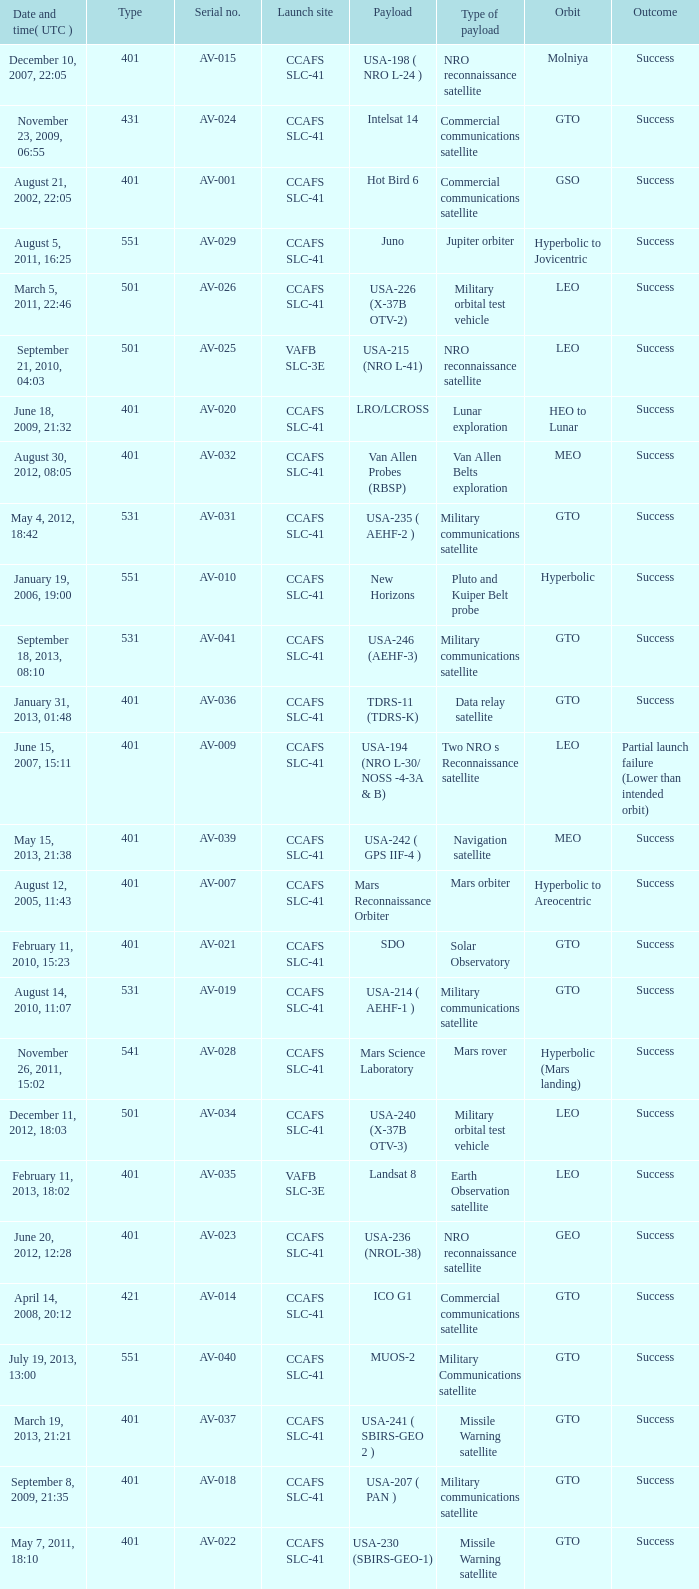When was the payload of Commercial Communications Satellite amc16? December 17, 2004, 12:07. 